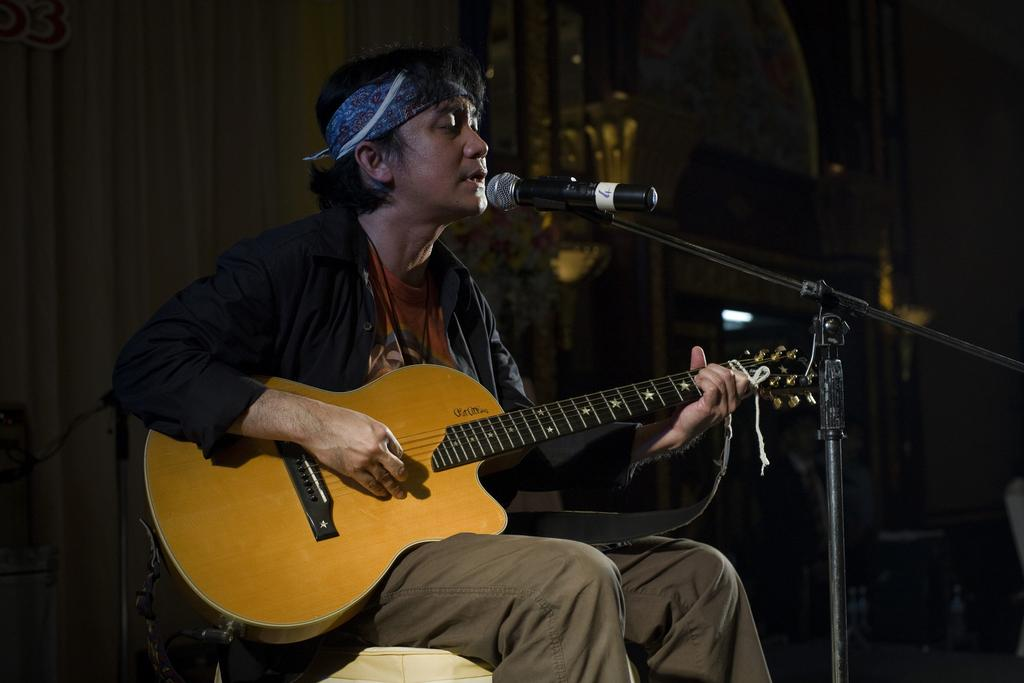What is the man in the image doing? The man is playing a guitar and singing into a microphone. What instrument is the man playing in the image? The man is playing a guitar. What is the man using to amplify his voice in the image? The man is using a microphone to amplify his voice. What grade did the man receive for his basketball skills in the image? There is no mention of basketball or grades in the image, so this question cannot be answered. 